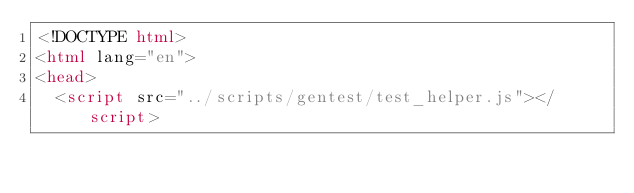<code> <loc_0><loc_0><loc_500><loc_500><_HTML_><!DOCTYPE html>
<html lang="en">
<head>
  <script src="../scripts/gentest/test_helper.js"></script></code> 